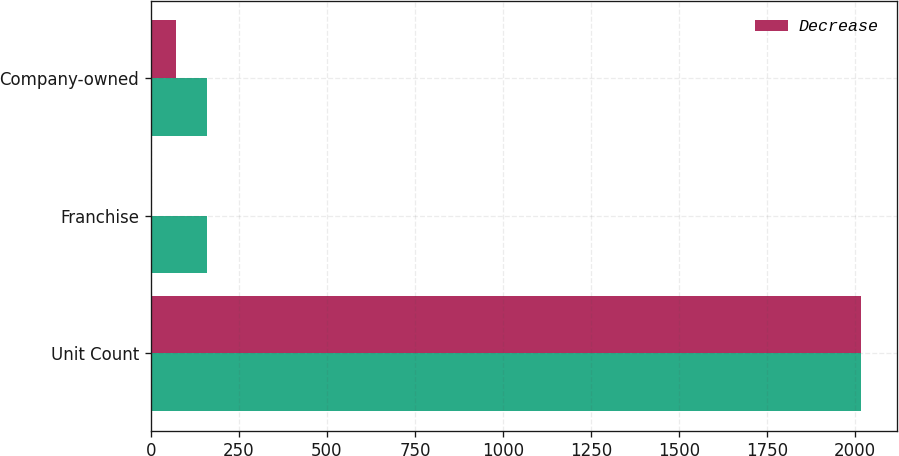<chart> <loc_0><loc_0><loc_500><loc_500><stacked_bar_chart><ecel><fcel>Unit Count<fcel>Franchise<fcel>Company-owned<nl><fcel>nan<fcel>2017<fcel>160<fcel>160<nl><fcel>Decrease<fcel>2017<fcel>5<fcel>71<nl></chart> 